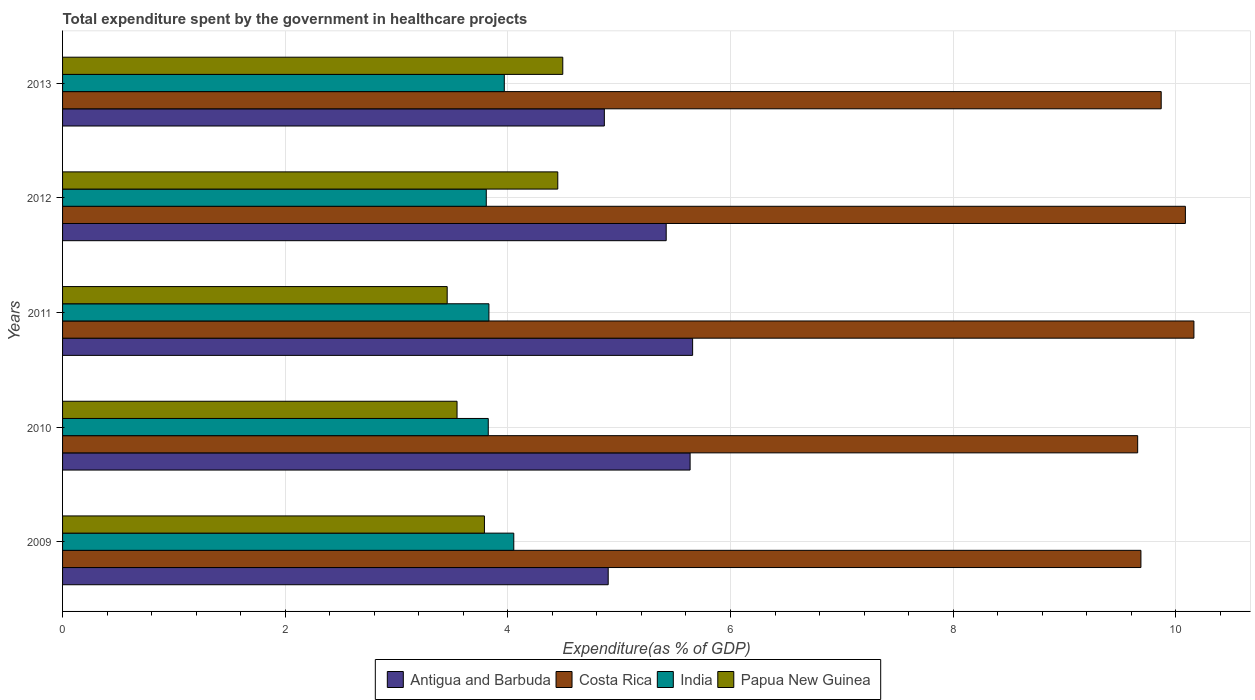Are the number of bars per tick equal to the number of legend labels?
Ensure brevity in your answer.  Yes. Are the number of bars on each tick of the Y-axis equal?
Keep it short and to the point. Yes. How many bars are there on the 3rd tick from the bottom?
Give a very brief answer. 4. What is the label of the 4th group of bars from the top?
Offer a very short reply. 2010. What is the total expenditure spent by the government in healthcare projects in India in 2012?
Keep it short and to the point. 3.81. Across all years, what is the maximum total expenditure spent by the government in healthcare projects in Papua New Guinea?
Keep it short and to the point. 4.49. Across all years, what is the minimum total expenditure spent by the government in healthcare projects in Antigua and Barbuda?
Provide a succinct answer. 4.87. In which year was the total expenditure spent by the government in healthcare projects in India minimum?
Offer a very short reply. 2012. What is the total total expenditure spent by the government in healthcare projects in India in the graph?
Offer a very short reply. 19.48. What is the difference between the total expenditure spent by the government in healthcare projects in Costa Rica in 2012 and that in 2013?
Offer a very short reply. 0.22. What is the difference between the total expenditure spent by the government in healthcare projects in India in 2011 and the total expenditure spent by the government in healthcare projects in Costa Rica in 2013?
Give a very brief answer. -6.04. What is the average total expenditure spent by the government in healthcare projects in India per year?
Provide a succinct answer. 3.9. In the year 2011, what is the difference between the total expenditure spent by the government in healthcare projects in Antigua and Barbuda and total expenditure spent by the government in healthcare projects in Papua New Guinea?
Make the answer very short. 2.2. In how many years, is the total expenditure spent by the government in healthcare projects in Papua New Guinea greater than 3.6 %?
Give a very brief answer. 3. What is the ratio of the total expenditure spent by the government in healthcare projects in India in 2011 to that in 2012?
Offer a very short reply. 1.01. What is the difference between the highest and the second highest total expenditure spent by the government in healthcare projects in Antigua and Barbuda?
Offer a terse response. 0.02. What is the difference between the highest and the lowest total expenditure spent by the government in healthcare projects in India?
Offer a terse response. 0.25. Is the sum of the total expenditure spent by the government in healthcare projects in Antigua and Barbuda in 2009 and 2010 greater than the maximum total expenditure spent by the government in healthcare projects in Costa Rica across all years?
Make the answer very short. Yes. What does the 1st bar from the top in 2010 represents?
Offer a terse response. Papua New Guinea. How many bars are there?
Give a very brief answer. 20. How many years are there in the graph?
Keep it short and to the point. 5. Are the values on the major ticks of X-axis written in scientific E-notation?
Provide a succinct answer. No. Does the graph contain any zero values?
Give a very brief answer. No. Does the graph contain grids?
Your answer should be very brief. Yes. Where does the legend appear in the graph?
Offer a very short reply. Bottom center. How many legend labels are there?
Offer a very short reply. 4. What is the title of the graph?
Keep it short and to the point. Total expenditure spent by the government in healthcare projects. What is the label or title of the X-axis?
Offer a terse response. Expenditure(as % of GDP). What is the Expenditure(as % of GDP) in Antigua and Barbuda in 2009?
Provide a succinct answer. 4.9. What is the Expenditure(as % of GDP) in Costa Rica in 2009?
Provide a succinct answer. 9.69. What is the Expenditure(as % of GDP) of India in 2009?
Keep it short and to the point. 4.05. What is the Expenditure(as % of GDP) in Papua New Guinea in 2009?
Offer a terse response. 3.79. What is the Expenditure(as % of GDP) of Antigua and Barbuda in 2010?
Keep it short and to the point. 5.64. What is the Expenditure(as % of GDP) of Costa Rica in 2010?
Ensure brevity in your answer.  9.66. What is the Expenditure(as % of GDP) of India in 2010?
Give a very brief answer. 3.82. What is the Expenditure(as % of GDP) in Papua New Guinea in 2010?
Ensure brevity in your answer.  3.54. What is the Expenditure(as % of GDP) of Antigua and Barbuda in 2011?
Offer a very short reply. 5.66. What is the Expenditure(as % of GDP) of Costa Rica in 2011?
Make the answer very short. 10.16. What is the Expenditure(as % of GDP) of India in 2011?
Offer a very short reply. 3.83. What is the Expenditure(as % of GDP) of Papua New Guinea in 2011?
Offer a terse response. 3.46. What is the Expenditure(as % of GDP) in Antigua and Barbuda in 2012?
Provide a short and direct response. 5.42. What is the Expenditure(as % of GDP) of Costa Rica in 2012?
Your answer should be very brief. 10.09. What is the Expenditure(as % of GDP) in India in 2012?
Keep it short and to the point. 3.81. What is the Expenditure(as % of GDP) in Papua New Guinea in 2012?
Keep it short and to the point. 4.45. What is the Expenditure(as % of GDP) of Antigua and Barbuda in 2013?
Your response must be concise. 4.87. What is the Expenditure(as % of GDP) in Costa Rica in 2013?
Give a very brief answer. 9.87. What is the Expenditure(as % of GDP) of India in 2013?
Provide a succinct answer. 3.97. What is the Expenditure(as % of GDP) in Papua New Guinea in 2013?
Your response must be concise. 4.49. Across all years, what is the maximum Expenditure(as % of GDP) in Antigua and Barbuda?
Give a very brief answer. 5.66. Across all years, what is the maximum Expenditure(as % of GDP) in Costa Rica?
Make the answer very short. 10.16. Across all years, what is the maximum Expenditure(as % of GDP) of India?
Keep it short and to the point. 4.05. Across all years, what is the maximum Expenditure(as % of GDP) of Papua New Guinea?
Make the answer very short. 4.49. Across all years, what is the minimum Expenditure(as % of GDP) in Antigua and Barbuda?
Your answer should be compact. 4.87. Across all years, what is the minimum Expenditure(as % of GDP) in Costa Rica?
Your response must be concise. 9.66. Across all years, what is the minimum Expenditure(as % of GDP) in India?
Keep it short and to the point. 3.81. Across all years, what is the minimum Expenditure(as % of GDP) of Papua New Guinea?
Ensure brevity in your answer.  3.46. What is the total Expenditure(as % of GDP) of Antigua and Barbuda in the graph?
Make the answer very short. 26.49. What is the total Expenditure(as % of GDP) in Costa Rica in the graph?
Provide a succinct answer. 49.46. What is the total Expenditure(as % of GDP) of India in the graph?
Give a very brief answer. 19.48. What is the total Expenditure(as % of GDP) in Papua New Guinea in the graph?
Your answer should be compact. 19.73. What is the difference between the Expenditure(as % of GDP) in Antigua and Barbuda in 2009 and that in 2010?
Your response must be concise. -0.74. What is the difference between the Expenditure(as % of GDP) of Costa Rica in 2009 and that in 2010?
Offer a terse response. 0.03. What is the difference between the Expenditure(as % of GDP) in India in 2009 and that in 2010?
Offer a terse response. 0.23. What is the difference between the Expenditure(as % of GDP) of Papua New Guinea in 2009 and that in 2010?
Make the answer very short. 0.25. What is the difference between the Expenditure(as % of GDP) in Antigua and Barbuda in 2009 and that in 2011?
Your answer should be compact. -0.76. What is the difference between the Expenditure(as % of GDP) in Costa Rica in 2009 and that in 2011?
Offer a very short reply. -0.48. What is the difference between the Expenditure(as % of GDP) of India in 2009 and that in 2011?
Your answer should be compact. 0.22. What is the difference between the Expenditure(as % of GDP) in Papua New Guinea in 2009 and that in 2011?
Provide a short and direct response. 0.33. What is the difference between the Expenditure(as % of GDP) in Antigua and Barbuda in 2009 and that in 2012?
Provide a succinct answer. -0.52. What is the difference between the Expenditure(as % of GDP) in Costa Rica in 2009 and that in 2012?
Your answer should be very brief. -0.4. What is the difference between the Expenditure(as % of GDP) in India in 2009 and that in 2012?
Your answer should be compact. 0.25. What is the difference between the Expenditure(as % of GDP) of Papua New Guinea in 2009 and that in 2012?
Make the answer very short. -0.66. What is the difference between the Expenditure(as % of GDP) of Antigua and Barbuda in 2009 and that in 2013?
Your answer should be compact. 0.03. What is the difference between the Expenditure(as % of GDP) of Costa Rica in 2009 and that in 2013?
Offer a terse response. -0.18. What is the difference between the Expenditure(as % of GDP) in India in 2009 and that in 2013?
Keep it short and to the point. 0.09. What is the difference between the Expenditure(as % of GDP) of Papua New Guinea in 2009 and that in 2013?
Your answer should be very brief. -0.7. What is the difference between the Expenditure(as % of GDP) of Antigua and Barbuda in 2010 and that in 2011?
Provide a short and direct response. -0.02. What is the difference between the Expenditure(as % of GDP) in Costa Rica in 2010 and that in 2011?
Your response must be concise. -0.51. What is the difference between the Expenditure(as % of GDP) of India in 2010 and that in 2011?
Offer a very short reply. -0.01. What is the difference between the Expenditure(as % of GDP) of Papua New Guinea in 2010 and that in 2011?
Offer a terse response. 0.09. What is the difference between the Expenditure(as % of GDP) in Antigua and Barbuda in 2010 and that in 2012?
Your answer should be compact. 0.21. What is the difference between the Expenditure(as % of GDP) of Costa Rica in 2010 and that in 2012?
Make the answer very short. -0.43. What is the difference between the Expenditure(as % of GDP) of India in 2010 and that in 2012?
Keep it short and to the point. 0.02. What is the difference between the Expenditure(as % of GDP) of Papua New Guinea in 2010 and that in 2012?
Make the answer very short. -0.91. What is the difference between the Expenditure(as % of GDP) in Antigua and Barbuda in 2010 and that in 2013?
Offer a very short reply. 0.77. What is the difference between the Expenditure(as % of GDP) of Costa Rica in 2010 and that in 2013?
Provide a short and direct response. -0.21. What is the difference between the Expenditure(as % of GDP) in India in 2010 and that in 2013?
Make the answer very short. -0.14. What is the difference between the Expenditure(as % of GDP) of Papua New Guinea in 2010 and that in 2013?
Give a very brief answer. -0.95. What is the difference between the Expenditure(as % of GDP) in Antigua and Barbuda in 2011 and that in 2012?
Your answer should be compact. 0.24. What is the difference between the Expenditure(as % of GDP) in Costa Rica in 2011 and that in 2012?
Your answer should be compact. 0.08. What is the difference between the Expenditure(as % of GDP) of India in 2011 and that in 2012?
Your response must be concise. 0.02. What is the difference between the Expenditure(as % of GDP) of Papua New Guinea in 2011 and that in 2012?
Provide a short and direct response. -0.99. What is the difference between the Expenditure(as % of GDP) of Antigua and Barbuda in 2011 and that in 2013?
Keep it short and to the point. 0.79. What is the difference between the Expenditure(as % of GDP) of Costa Rica in 2011 and that in 2013?
Give a very brief answer. 0.29. What is the difference between the Expenditure(as % of GDP) of India in 2011 and that in 2013?
Make the answer very short. -0.14. What is the difference between the Expenditure(as % of GDP) of Papua New Guinea in 2011 and that in 2013?
Keep it short and to the point. -1.04. What is the difference between the Expenditure(as % of GDP) of Antigua and Barbuda in 2012 and that in 2013?
Your response must be concise. 0.56. What is the difference between the Expenditure(as % of GDP) in Costa Rica in 2012 and that in 2013?
Your answer should be compact. 0.22. What is the difference between the Expenditure(as % of GDP) of India in 2012 and that in 2013?
Ensure brevity in your answer.  -0.16. What is the difference between the Expenditure(as % of GDP) in Papua New Guinea in 2012 and that in 2013?
Give a very brief answer. -0.04. What is the difference between the Expenditure(as % of GDP) in Antigua and Barbuda in 2009 and the Expenditure(as % of GDP) in Costa Rica in 2010?
Your answer should be very brief. -4.76. What is the difference between the Expenditure(as % of GDP) of Antigua and Barbuda in 2009 and the Expenditure(as % of GDP) of India in 2010?
Give a very brief answer. 1.08. What is the difference between the Expenditure(as % of GDP) of Antigua and Barbuda in 2009 and the Expenditure(as % of GDP) of Papua New Guinea in 2010?
Ensure brevity in your answer.  1.36. What is the difference between the Expenditure(as % of GDP) in Costa Rica in 2009 and the Expenditure(as % of GDP) in India in 2010?
Offer a terse response. 5.86. What is the difference between the Expenditure(as % of GDP) in Costa Rica in 2009 and the Expenditure(as % of GDP) in Papua New Guinea in 2010?
Your answer should be very brief. 6.14. What is the difference between the Expenditure(as % of GDP) in India in 2009 and the Expenditure(as % of GDP) in Papua New Guinea in 2010?
Your answer should be compact. 0.51. What is the difference between the Expenditure(as % of GDP) of Antigua and Barbuda in 2009 and the Expenditure(as % of GDP) of Costa Rica in 2011?
Make the answer very short. -5.26. What is the difference between the Expenditure(as % of GDP) of Antigua and Barbuda in 2009 and the Expenditure(as % of GDP) of India in 2011?
Your answer should be very brief. 1.07. What is the difference between the Expenditure(as % of GDP) in Antigua and Barbuda in 2009 and the Expenditure(as % of GDP) in Papua New Guinea in 2011?
Your answer should be compact. 1.45. What is the difference between the Expenditure(as % of GDP) of Costa Rica in 2009 and the Expenditure(as % of GDP) of India in 2011?
Offer a very short reply. 5.86. What is the difference between the Expenditure(as % of GDP) in Costa Rica in 2009 and the Expenditure(as % of GDP) in Papua New Guinea in 2011?
Ensure brevity in your answer.  6.23. What is the difference between the Expenditure(as % of GDP) in India in 2009 and the Expenditure(as % of GDP) in Papua New Guinea in 2011?
Offer a very short reply. 0.6. What is the difference between the Expenditure(as % of GDP) in Antigua and Barbuda in 2009 and the Expenditure(as % of GDP) in Costa Rica in 2012?
Provide a short and direct response. -5.18. What is the difference between the Expenditure(as % of GDP) in Antigua and Barbuda in 2009 and the Expenditure(as % of GDP) in India in 2012?
Provide a succinct answer. 1.1. What is the difference between the Expenditure(as % of GDP) in Antigua and Barbuda in 2009 and the Expenditure(as % of GDP) in Papua New Guinea in 2012?
Your answer should be compact. 0.45. What is the difference between the Expenditure(as % of GDP) in Costa Rica in 2009 and the Expenditure(as % of GDP) in India in 2012?
Ensure brevity in your answer.  5.88. What is the difference between the Expenditure(as % of GDP) in Costa Rica in 2009 and the Expenditure(as % of GDP) in Papua New Guinea in 2012?
Offer a terse response. 5.24. What is the difference between the Expenditure(as % of GDP) in India in 2009 and the Expenditure(as % of GDP) in Papua New Guinea in 2012?
Provide a short and direct response. -0.4. What is the difference between the Expenditure(as % of GDP) in Antigua and Barbuda in 2009 and the Expenditure(as % of GDP) in Costa Rica in 2013?
Your answer should be compact. -4.97. What is the difference between the Expenditure(as % of GDP) in Antigua and Barbuda in 2009 and the Expenditure(as % of GDP) in India in 2013?
Make the answer very short. 0.93. What is the difference between the Expenditure(as % of GDP) in Antigua and Barbuda in 2009 and the Expenditure(as % of GDP) in Papua New Guinea in 2013?
Keep it short and to the point. 0.41. What is the difference between the Expenditure(as % of GDP) in Costa Rica in 2009 and the Expenditure(as % of GDP) in India in 2013?
Ensure brevity in your answer.  5.72. What is the difference between the Expenditure(as % of GDP) of Costa Rica in 2009 and the Expenditure(as % of GDP) of Papua New Guinea in 2013?
Your response must be concise. 5.19. What is the difference between the Expenditure(as % of GDP) in India in 2009 and the Expenditure(as % of GDP) in Papua New Guinea in 2013?
Ensure brevity in your answer.  -0.44. What is the difference between the Expenditure(as % of GDP) in Antigua and Barbuda in 2010 and the Expenditure(as % of GDP) in Costa Rica in 2011?
Offer a very short reply. -4.53. What is the difference between the Expenditure(as % of GDP) of Antigua and Barbuda in 2010 and the Expenditure(as % of GDP) of India in 2011?
Your answer should be compact. 1.81. What is the difference between the Expenditure(as % of GDP) of Antigua and Barbuda in 2010 and the Expenditure(as % of GDP) of Papua New Guinea in 2011?
Your response must be concise. 2.18. What is the difference between the Expenditure(as % of GDP) in Costa Rica in 2010 and the Expenditure(as % of GDP) in India in 2011?
Keep it short and to the point. 5.83. What is the difference between the Expenditure(as % of GDP) in Costa Rica in 2010 and the Expenditure(as % of GDP) in Papua New Guinea in 2011?
Your response must be concise. 6.2. What is the difference between the Expenditure(as % of GDP) in India in 2010 and the Expenditure(as % of GDP) in Papua New Guinea in 2011?
Offer a very short reply. 0.37. What is the difference between the Expenditure(as % of GDP) in Antigua and Barbuda in 2010 and the Expenditure(as % of GDP) in Costa Rica in 2012?
Offer a terse response. -4.45. What is the difference between the Expenditure(as % of GDP) of Antigua and Barbuda in 2010 and the Expenditure(as % of GDP) of India in 2012?
Ensure brevity in your answer.  1.83. What is the difference between the Expenditure(as % of GDP) of Antigua and Barbuda in 2010 and the Expenditure(as % of GDP) of Papua New Guinea in 2012?
Give a very brief answer. 1.19. What is the difference between the Expenditure(as % of GDP) of Costa Rica in 2010 and the Expenditure(as % of GDP) of India in 2012?
Give a very brief answer. 5.85. What is the difference between the Expenditure(as % of GDP) in Costa Rica in 2010 and the Expenditure(as % of GDP) in Papua New Guinea in 2012?
Your answer should be compact. 5.21. What is the difference between the Expenditure(as % of GDP) in India in 2010 and the Expenditure(as % of GDP) in Papua New Guinea in 2012?
Your response must be concise. -0.62. What is the difference between the Expenditure(as % of GDP) in Antigua and Barbuda in 2010 and the Expenditure(as % of GDP) in Costa Rica in 2013?
Ensure brevity in your answer.  -4.23. What is the difference between the Expenditure(as % of GDP) of Antigua and Barbuda in 2010 and the Expenditure(as % of GDP) of India in 2013?
Provide a succinct answer. 1.67. What is the difference between the Expenditure(as % of GDP) in Antigua and Barbuda in 2010 and the Expenditure(as % of GDP) in Papua New Guinea in 2013?
Offer a very short reply. 1.14. What is the difference between the Expenditure(as % of GDP) of Costa Rica in 2010 and the Expenditure(as % of GDP) of India in 2013?
Give a very brief answer. 5.69. What is the difference between the Expenditure(as % of GDP) in Costa Rica in 2010 and the Expenditure(as % of GDP) in Papua New Guinea in 2013?
Ensure brevity in your answer.  5.16. What is the difference between the Expenditure(as % of GDP) in India in 2010 and the Expenditure(as % of GDP) in Papua New Guinea in 2013?
Ensure brevity in your answer.  -0.67. What is the difference between the Expenditure(as % of GDP) of Antigua and Barbuda in 2011 and the Expenditure(as % of GDP) of Costa Rica in 2012?
Your answer should be very brief. -4.43. What is the difference between the Expenditure(as % of GDP) in Antigua and Barbuda in 2011 and the Expenditure(as % of GDP) in India in 2012?
Give a very brief answer. 1.85. What is the difference between the Expenditure(as % of GDP) of Antigua and Barbuda in 2011 and the Expenditure(as % of GDP) of Papua New Guinea in 2012?
Ensure brevity in your answer.  1.21. What is the difference between the Expenditure(as % of GDP) of Costa Rica in 2011 and the Expenditure(as % of GDP) of India in 2012?
Your answer should be very brief. 6.36. What is the difference between the Expenditure(as % of GDP) in Costa Rica in 2011 and the Expenditure(as % of GDP) in Papua New Guinea in 2012?
Your answer should be very brief. 5.71. What is the difference between the Expenditure(as % of GDP) of India in 2011 and the Expenditure(as % of GDP) of Papua New Guinea in 2012?
Offer a very short reply. -0.62. What is the difference between the Expenditure(as % of GDP) of Antigua and Barbuda in 2011 and the Expenditure(as % of GDP) of Costa Rica in 2013?
Offer a very short reply. -4.21. What is the difference between the Expenditure(as % of GDP) of Antigua and Barbuda in 2011 and the Expenditure(as % of GDP) of India in 2013?
Give a very brief answer. 1.69. What is the difference between the Expenditure(as % of GDP) in Antigua and Barbuda in 2011 and the Expenditure(as % of GDP) in Papua New Guinea in 2013?
Offer a terse response. 1.17. What is the difference between the Expenditure(as % of GDP) of Costa Rica in 2011 and the Expenditure(as % of GDP) of India in 2013?
Provide a short and direct response. 6.19. What is the difference between the Expenditure(as % of GDP) in Costa Rica in 2011 and the Expenditure(as % of GDP) in Papua New Guinea in 2013?
Your answer should be very brief. 5.67. What is the difference between the Expenditure(as % of GDP) of India in 2011 and the Expenditure(as % of GDP) of Papua New Guinea in 2013?
Offer a very short reply. -0.66. What is the difference between the Expenditure(as % of GDP) in Antigua and Barbuda in 2012 and the Expenditure(as % of GDP) in Costa Rica in 2013?
Offer a terse response. -4.45. What is the difference between the Expenditure(as % of GDP) in Antigua and Barbuda in 2012 and the Expenditure(as % of GDP) in India in 2013?
Offer a very short reply. 1.45. What is the difference between the Expenditure(as % of GDP) of Antigua and Barbuda in 2012 and the Expenditure(as % of GDP) of Papua New Guinea in 2013?
Offer a terse response. 0.93. What is the difference between the Expenditure(as % of GDP) of Costa Rica in 2012 and the Expenditure(as % of GDP) of India in 2013?
Make the answer very short. 6.12. What is the difference between the Expenditure(as % of GDP) of Costa Rica in 2012 and the Expenditure(as % of GDP) of Papua New Guinea in 2013?
Your answer should be very brief. 5.59. What is the difference between the Expenditure(as % of GDP) in India in 2012 and the Expenditure(as % of GDP) in Papua New Guinea in 2013?
Provide a succinct answer. -0.69. What is the average Expenditure(as % of GDP) of Antigua and Barbuda per year?
Your answer should be very brief. 5.3. What is the average Expenditure(as % of GDP) in Costa Rica per year?
Offer a very short reply. 9.89. What is the average Expenditure(as % of GDP) in India per year?
Provide a short and direct response. 3.9. What is the average Expenditure(as % of GDP) of Papua New Guinea per year?
Provide a succinct answer. 3.95. In the year 2009, what is the difference between the Expenditure(as % of GDP) of Antigua and Barbuda and Expenditure(as % of GDP) of Costa Rica?
Keep it short and to the point. -4.79. In the year 2009, what is the difference between the Expenditure(as % of GDP) of Antigua and Barbuda and Expenditure(as % of GDP) of India?
Make the answer very short. 0.85. In the year 2009, what is the difference between the Expenditure(as % of GDP) in Antigua and Barbuda and Expenditure(as % of GDP) in Papua New Guinea?
Make the answer very short. 1.11. In the year 2009, what is the difference between the Expenditure(as % of GDP) in Costa Rica and Expenditure(as % of GDP) in India?
Give a very brief answer. 5.63. In the year 2009, what is the difference between the Expenditure(as % of GDP) of Costa Rica and Expenditure(as % of GDP) of Papua New Guinea?
Provide a short and direct response. 5.9. In the year 2009, what is the difference between the Expenditure(as % of GDP) in India and Expenditure(as % of GDP) in Papua New Guinea?
Give a very brief answer. 0.26. In the year 2010, what is the difference between the Expenditure(as % of GDP) of Antigua and Barbuda and Expenditure(as % of GDP) of Costa Rica?
Your answer should be very brief. -4.02. In the year 2010, what is the difference between the Expenditure(as % of GDP) of Antigua and Barbuda and Expenditure(as % of GDP) of India?
Offer a terse response. 1.81. In the year 2010, what is the difference between the Expenditure(as % of GDP) of Antigua and Barbuda and Expenditure(as % of GDP) of Papua New Guinea?
Your answer should be compact. 2.09. In the year 2010, what is the difference between the Expenditure(as % of GDP) of Costa Rica and Expenditure(as % of GDP) of India?
Offer a very short reply. 5.83. In the year 2010, what is the difference between the Expenditure(as % of GDP) of Costa Rica and Expenditure(as % of GDP) of Papua New Guinea?
Provide a succinct answer. 6.11. In the year 2010, what is the difference between the Expenditure(as % of GDP) of India and Expenditure(as % of GDP) of Papua New Guinea?
Ensure brevity in your answer.  0.28. In the year 2011, what is the difference between the Expenditure(as % of GDP) in Antigua and Barbuda and Expenditure(as % of GDP) in Costa Rica?
Give a very brief answer. -4.5. In the year 2011, what is the difference between the Expenditure(as % of GDP) in Antigua and Barbuda and Expenditure(as % of GDP) in India?
Offer a terse response. 1.83. In the year 2011, what is the difference between the Expenditure(as % of GDP) of Antigua and Barbuda and Expenditure(as % of GDP) of Papua New Guinea?
Provide a short and direct response. 2.2. In the year 2011, what is the difference between the Expenditure(as % of GDP) of Costa Rica and Expenditure(as % of GDP) of India?
Make the answer very short. 6.33. In the year 2011, what is the difference between the Expenditure(as % of GDP) of Costa Rica and Expenditure(as % of GDP) of Papua New Guinea?
Your answer should be very brief. 6.71. In the year 2011, what is the difference between the Expenditure(as % of GDP) of India and Expenditure(as % of GDP) of Papua New Guinea?
Your response must be concise. 0.37. In the year 2012, what is the difference between the Expenditure(as % of GDP) in Antigua and Barbuda and Expenditure(as % of GDP) in Costa Rica?
Offer a terse response. -4.66. In the year 2012, what is the difference between the Expenditure(as % of GDP) in Antigua and Barbuda and Expenditure(as % of GDP) in India?
Give a very brief answer. 1.62. In the year 2012, what is the difference between the Expenditure(as % of GDP) of Antigua and Barbuda and Expenditure(as % of GDP) of Papua New Guinea?
Ensure brevity in your answer.  0.97. In the year 2012, what is the difference between the Expenditure(as % of GDP) of Costa Rica and Expenditure(as % of GDP) of India?
Make the answer very short. 6.28. In the year 2012, what is the difference between the Expenditure(as % of GDP) of Costa Rica and Expenditure(as % of GDP) of Papua New Guinea?
Provide a short and direct response. 5.64. In the year 2012, what is the difference between the Expenditure(as % of GDP) of India and Expenditure(as % of GDP) of Papua New Guinea?
Provide a short and direct response. -0.64. In the year 2013, what is the difference between the Expenditure(as % of GDP) of Antigua and Barbuda and Expenditure(as % of GDP) of Costa Rica?
Your response must be concise. -5. In the year 2013, what is the difference between the Expenditure(as % of GDP) of Antigua and Barbuda and Expenditure(as % of GDP) of India?
Your answer should be compact. 0.9. In the year 2013, what is the difference between the Expenditure(as % of GDP) in Antigua and Barbuda and Expenditure(as % of GDP) in Papua New Guinea?
Make the answer very short. 0.37. In the year 2013, what is the difference between the Expenditure(as % of GDP) of Costa Rica and Expenditure(as % of GDP) of India?
Give a very brief answer. 5.9. In the year 2013, what is the difference between the Expenditure(as % of GDP) of Costa Rica and Expenditure(as % of GDP) of Papua New Guinea?
Your response must be concise. 5.38. In the year 2013, what is the difference between the Expenditure(as % of GDP) of India and Expenditure(as % of GDP) of Papua New Guinea?
Your answer should be compact. -0.53. What is the ratio of the Expenditure(as % of GDP) of Antigua and Barbuda in 2009 to that in 2010?
Your answer should be compact. 0.87. What is the ratio of the Expenditure(as % of GDP) of Costa Rica in 2009 to that in 2010?
Make the answer very short. 1. What is the ratio of the Expenditure(as % of GDP) of India in 2009 to that in 2010?
Provide a short and direct response. 1.06. What is the ratio of the Expenditure(as % of GDP) in Papua New Guinea in 2009 to that in 2010?
Provide a succinct answer. 1.07. What is the ratio of the Expenditure(as % of GDP) in Antigua and Barbuda in 2009 to that in 2011?
Offer a terse response. 0.87. What is the ratio of the Expenditure(as % of GDP) in Costa Rica in 2009 to that in 2011?
Provide a short and direct response. 0.95. What is the ratio of the Expenditure(as % of GDP) in India in 2009 to that in 2011?
Your answer should be compact. 1.06. What is the ratio of the Expenditure(as % of GDP) of Papua New Guinea in 2009 to that in 2011?
Give a very brief answer. 1.1. What is the ratio of the Expenditure(as % of GDP) in Antigua and Barbuda in 2009 to that in 2012?
Make the answer very short. 0.9. What is the ratio of the Expenditure(as % of GDP) of Costa Rica in 2009 to that in 2012?
Your answer should be compact. 0.96. What is the ratio of the Expenditure(as % of GDP) of India in 2009 to that in 2012?
Ensure brevity in your answer.  1.06. What is the ratio of the Expenditure(as % of GDP) in Papua New Guinea in 2009 to that in 2012?
Provide a succinct answer. 0.85. What is the ratio of the Expenditure(as % of GDP) in Antigua and Barbuda in 2009 to that in 2013?
Your response must be concise. 1.01. What is the ratio of the Expenditure(as % of GDP) in Costa Rica in 2009 to that in 2013?
Keep it short and to the point. 0.98. What is the ratio of the Expenditure(as % of GDP) in India in 2009 to that in 2013?
Your answer should be very brief. 1.02. What is the ratio of the Expenditure(as % of GDP) of Papua New Guinea in 2009 to that in 2013?
Ensure brevity in your answer.  0.84. What is the ratio of the Expenditure(as % of GDP) in Antigua and Barbuda in 2010 to that in 2011?
Make the answer very short. 1. What is the ratio of the Expenditure(as % of GDP) of Costa Rica in 2010 to that in 2011?
Offer a terse response. 0.95. What is the ratio of the Expenditure(as % of GDP) of Papua New Guinea in 2010 to that in 2011?
Your response must be concise. 1.03. What is the ratio of the Expenditure(as % of GDP) in Antigua and Barbuda in 2010 to that in 2012?
Give a very brief answer. 1.04. What is the ratio of the Expenditure(as % of GDP) of Costa Rica in 2010 to that in 2012?
Offer a very short reply. 0.96. What is the ratio of the Expenditure(as % of GDP) of Papua New Guinea in 2010 to that in 2012?
Ensure brevity in your answer.  0.8. What is the ratio of the Expenditure(as % of GDP) of Antigua and Barbuda in 2010 to that in 2013?
Provide a short and direct response. 1.16. What is the ratio of the Expenditure(as % of GDP) of Costa Rica in 2010 to that in 2013?
Give a very brief answer. 0.98. What is the ratio of the Expenditure(as % of GDP) in India in 2010 to that in 2013?
Ensure brevity in your answer.  0.96. What is the ratio of the Expenditure(as % of GDP) in Papua New Guinea in 2010 to that in 2013?
Your response must be concise. 0.79. What is the ratio of the Expenditure(as % of GDP) of Antigua and Barbuda in 2011 to that in 2012?
Make the answer very short. 1.04. What is the ratio of the Expenditure(as % of GDP) in Costa Rica in 2011 to that in 2012?
Make the answer very short. 1.01. What is the ratio of the Expenditure(as % of GDP) in India in 2011 to that in 2012?
Ensure brevity in your answer.  1.01. What is the ratio of the Expenditure(as % of GDP) of Papua New Guinea in 2011 to that in 2012?
Your answer should be compact. 0.78. What is the ratio of the Expenditure(as % of GDP) of Antigua and Barbuda in 2011 to that in 2013?
Give a very brief answer. 1.16. What is the ratio of the Expenditure(as % of GDP) in Costa Rica in 2011 to that in 2013?
Offer a very short reply. 1.03. What is the ratio of the Expenditure(as % of GDP) in India in 2011 to that in 2013?
Your answer should be very brief. 0.97. What is the ratio of the Expenditure(as % of GDP) in Papua New Guinea in 2011 to that in 2013?
Make the answer very short. 0.77. What is the ratio of the Expenditure(as % of GDP) in Antigua and Barbuda in 2012 to that in 2013?
Offer a terse response. 1.11. What is the ratio of the Expenditure(as % of GDP) in India in 2012 to that in 2013?
Provide a succinct answer. 0.96. What is the ratio of the Expenditure(as % of GDP) of Papua New Guinea in 2012 to that in 2013?
Make the answer very short. 0.99. What is the difference between the highest and the second highest Expenditure(as % of GDP) of Antigua and Barbuda?
Your answer should be compact. 0.02. What is the difference between the highest and the second highest Expenditure(as % of GDP) of Costa Rica?
Provide a succinct answer. 0.08. What is the difference between the highest and the second highest Expenditure(as % of GDP) of India?
Your answer should be very brief. 0.09. What is the difference between the highest and the second highest Expenditure(as % of GDP) in Papua New Guinea?
Keep it short and to the point. 0.04. What is the difference between the highest and the lowest Expenditure(as % of GDP) of Antigua and Barbuda?
Provide a short and direct response. 0.79. What is the difference between the highest and the lowest Expenditure(as % of GDP) in Costa Rica?
Offer a very short reply. 0.51. What is the difference between the highest and the lowest Expenditure(as % of GDP) of India?
Provide a succinct answer. 0.25. What is the difference between the highest and the lowest Expenditure(as % of GDP) in Papua New Guinea?
Ensure brevity in your answer.  1.04. 